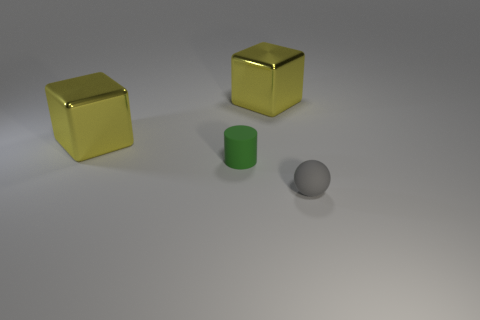Are there any yellow blocks of the same size as the green object?
Provide a succinct answer. No. Does the small thing to the left of the gray matte object have the same material as the gray thing?
Make the answer very short. Yes. Are there an equal number of gray matte objects that are in front of the gray object and small rubber cylinders on the left side of the tiny green matte cylinder?
Provide a short and direct response. Yes. The object that is both behind the gray rubber sphere and right of the green cylinder has what shape?
Your response must be concise. Cube. How many tiny cylinders are right of the green object?
Your answer should be compact. 0. How many other objects are the same shape as the green matte object?
Give a very brief answer. 0. Is the number of balls less than the number of tiny gray matte cylinders?
Provide a succinct answer. No. There is a thing that is both to the right of the small green object and to the left of the matte sphere; what size is it?
Ensure brevity in your answer.  Large. There is a metal cube that is to the left of the tiny object that is behind the small object that is right of the tiny rubber cylinder; what size is it?
Make the answer very short. Large. What is the size of the gray matte object?
Give a very brief answer. Small. 